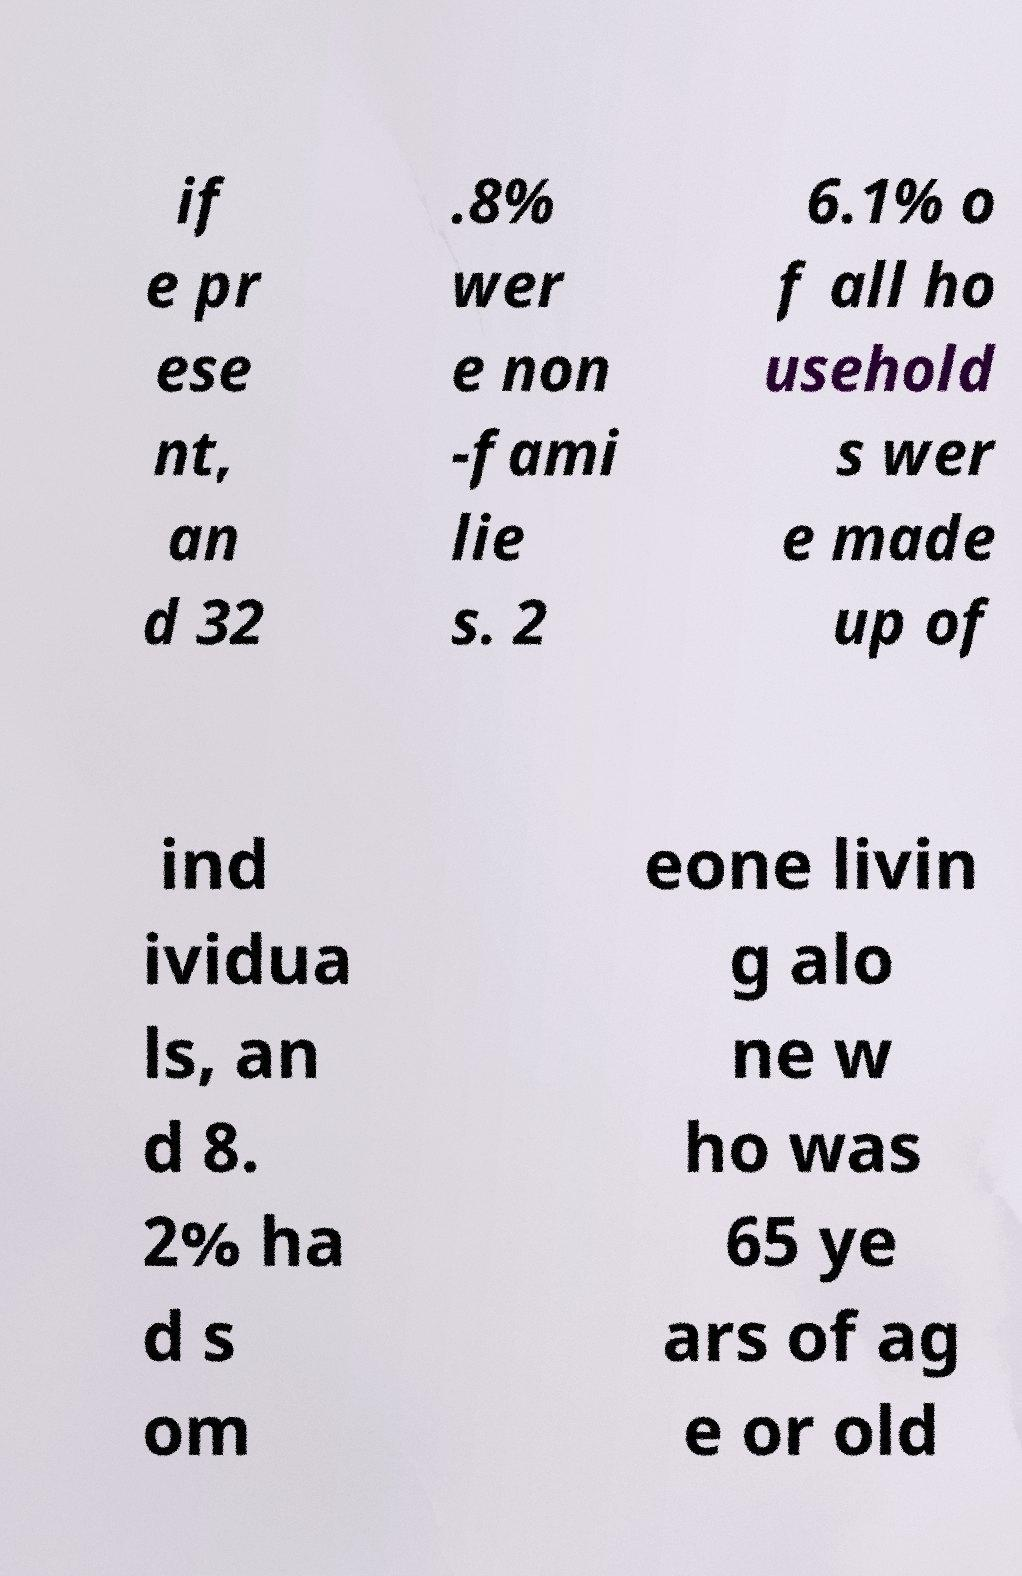For documentation purposes, I need the text within this image transcribed. Could you provide that? if e pr ese nt, an d 32 .8% wer e non -fami lie s. 2 6.1% o f all ho usehold s wer e made up of ind ividua ls, an d 8. 2% ha d s om eone livin g alo ne w ho was 65 ye ars of ag e or old 